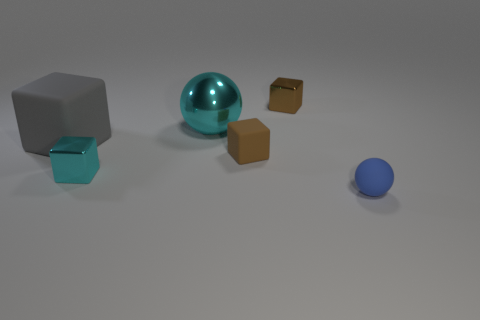There is a brown object behind the matte object behind the small rubber cube; is there a small metallic thing behind it?
Keep it short and to the point. No. The thing that is the same color as the small rubber block is what shape?
Offer a very short reply. Cube. What number of big things are either blocks or red rubber things?
Your response must be concise. 1. Do the small matte thing to the left of the tiny blue object and the gray thing have the same shape?
Give a very brief answer. Yes. Are there fewer small cyan objects than tiny green matte cubes?
Make the answer very short. No. Are there any other things of the same color as the small rubber ball?
Your answer should be very brief. No. What shape is the tiny brown thing that is in front of the large metallic ball?
Make the answer very short. Cube. Is the color of the big sphere the same as the tiny matte sphere that is in front of the cyan metallic ball?
Provide a short and direct response. No. Are there the same number of metallic balls that are in front of the blue object and large gray objects left of the large cube?
Your response must be concise. Yes. What number of other objects are the same size as the brown metallic block?
Provide a succinct answer. 3. 